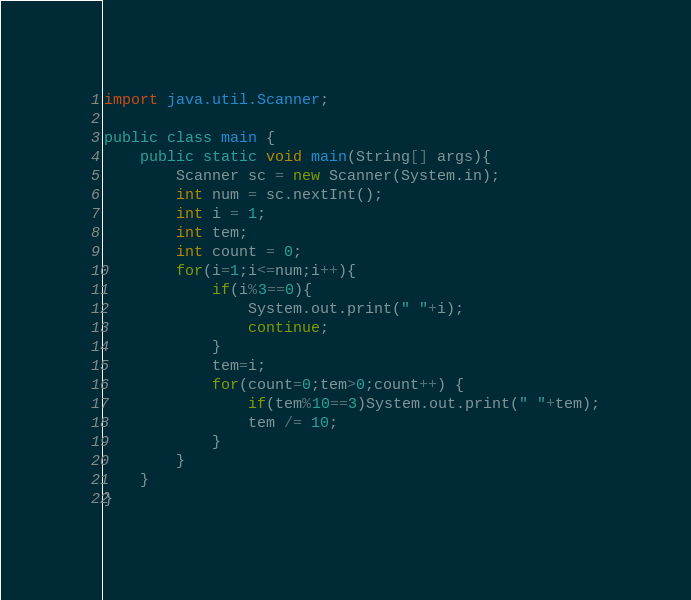Convert code to text. <code><loc_0><loc_0><loc_500><loc_500><_Java_>import java.util.Scanner;

public class main {
    public static void main(String[] args){
        Scanner sc = new Scanner(System.in);
        int num = sc.nextInt();
        int i = 1;
        int tem;
        int count = 0;
        for(i=1;i<=num;i++){
            if(i%3==0){
                System.out.print(" "+i);
                continue;
            }
            tem=i;
            for(count=0;tem>0;count++) {
                if(tem%10==3)System.out.print(" "+tem);
                tem /= 10;
            }
        }
    }
}
</code> 